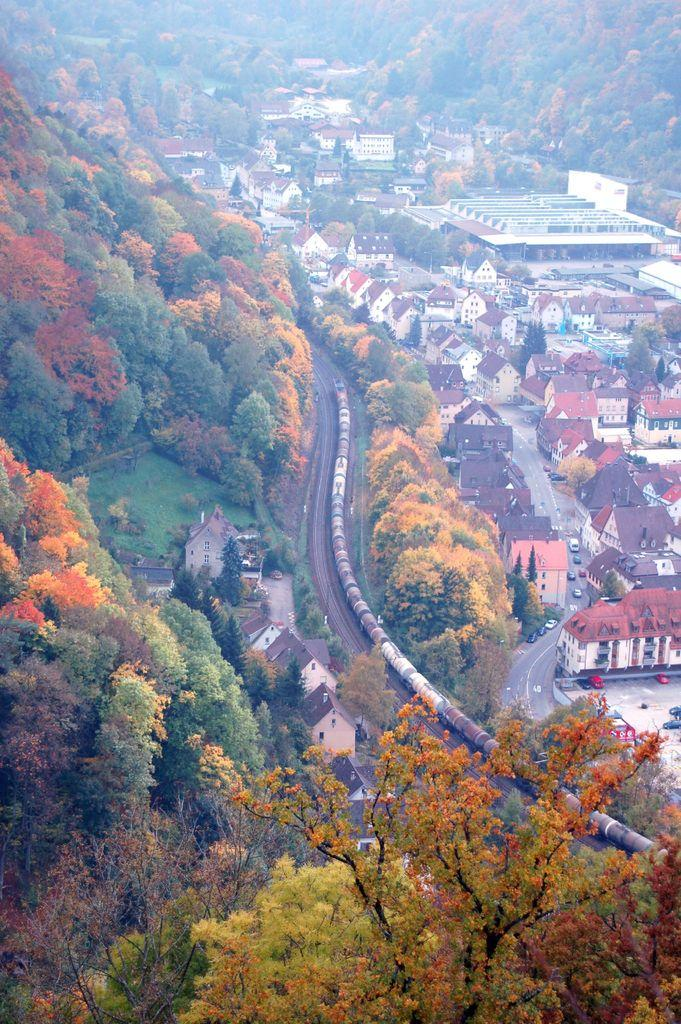What is the primary feature of the landscape in the image? There are many trees in the image. What mode of transportation can be seen in the image? There is a goods train in the image. What type of structures are present in the image? There are multiple buildings in the image. What type of popcorn is being served at the train station in the image? There is no indication of popcorn or a train station in the image; it features trees, a goods train, and buildings. How does the nerve of the train affect the pollution in the image? There is no mention of a train's nerve or pollution in the image. 